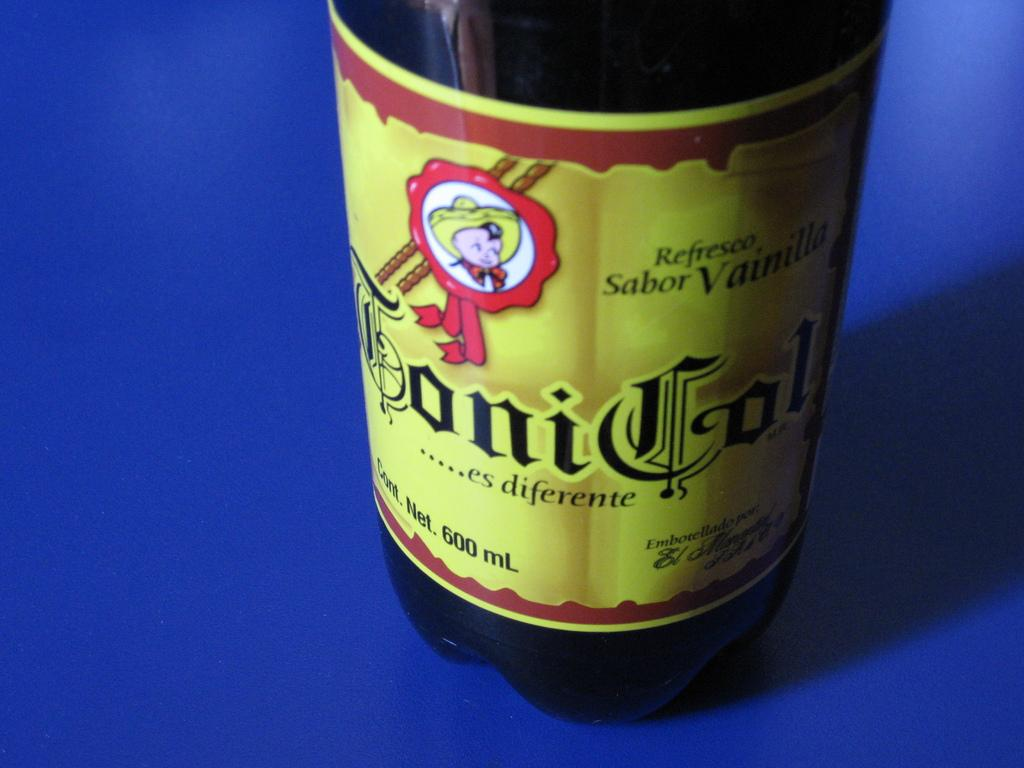<image>
Summarize the visual content of the image. A boy in a yellow hat is on the label of the Toni Col drink. 